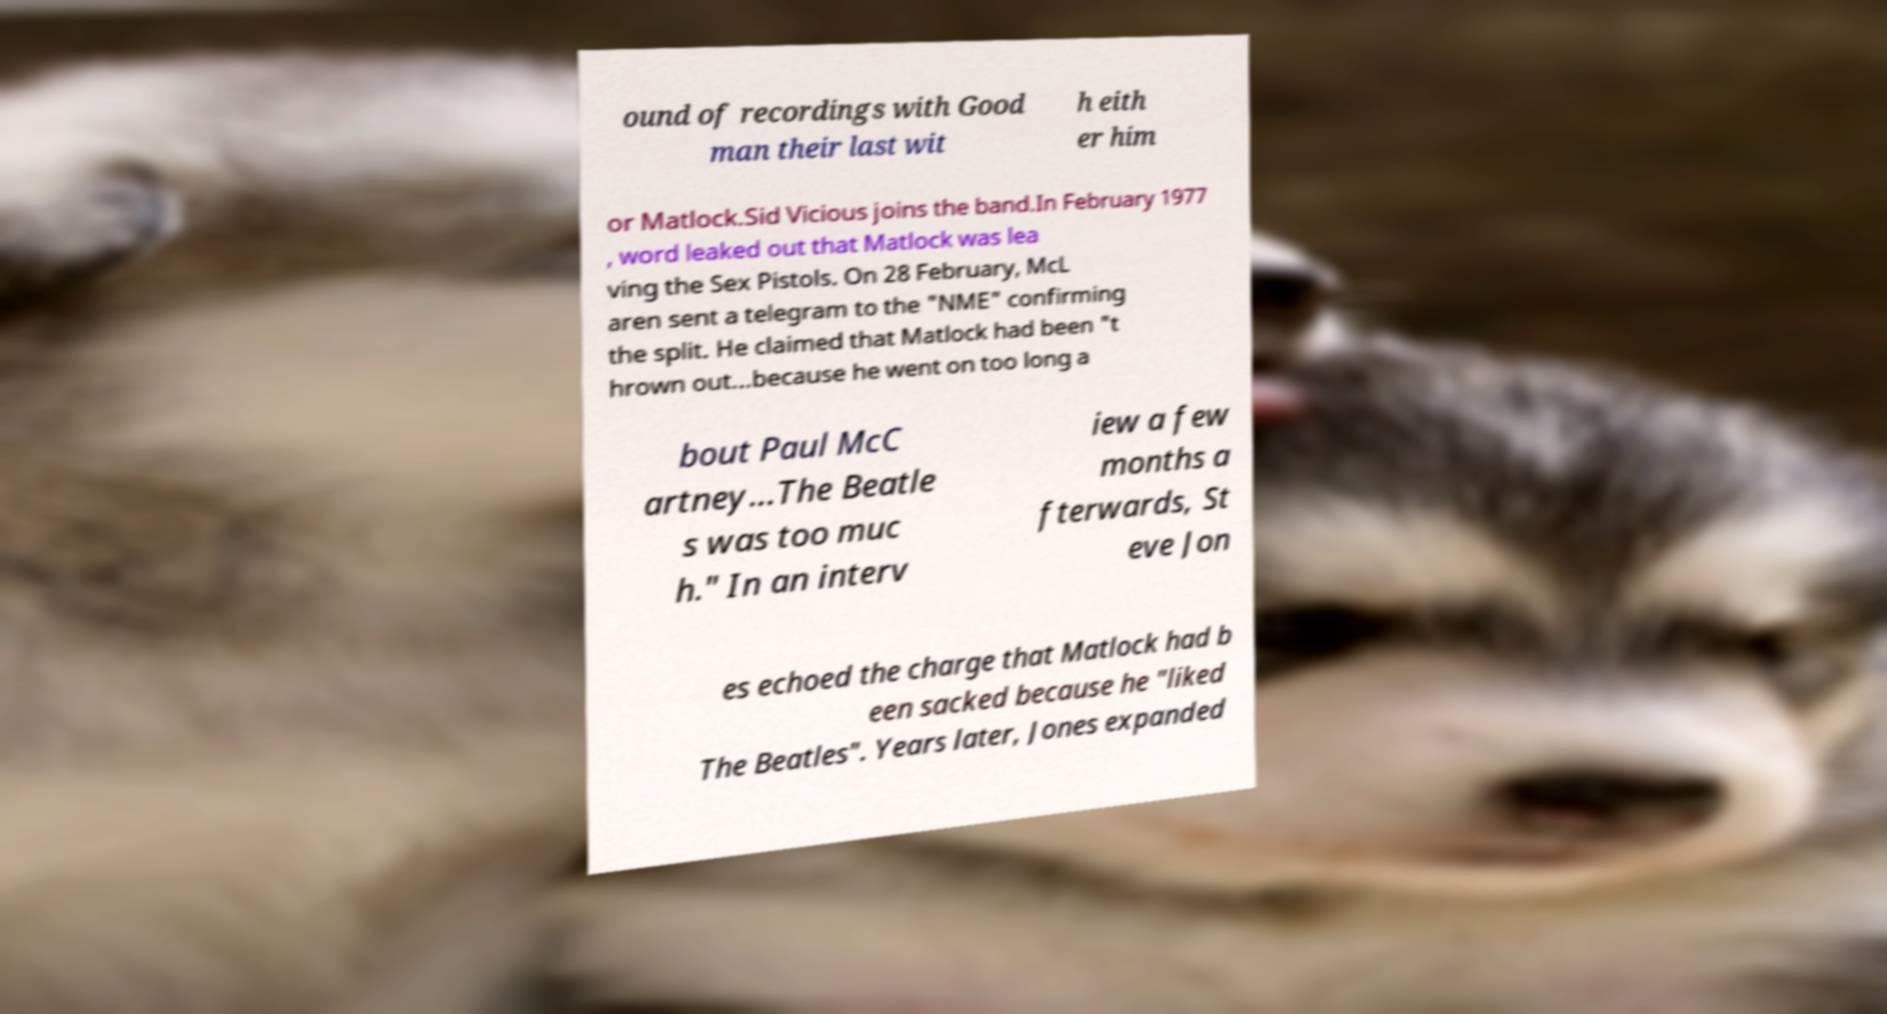Could you extract and type out the text from this image? ound of recordings with Good man their last wit h eith er him or Matlock.Sid Vicious joins the band.In February 1977 , word leaked out that Matlock was lea ving the Sex Pistols. On 28 February, McL aren sent a telegram to the "NME" confirming the split. He claimed that Matlock had been "t hrown out...because he went on too long a bout Paul McC artney...The Beatle s was too muc h." In an interv iew a few months a fterwards, St eve Jon es echoed the charge that Matlock had b een sacked because he "liked The Beatles". Years later, Jones expanded 